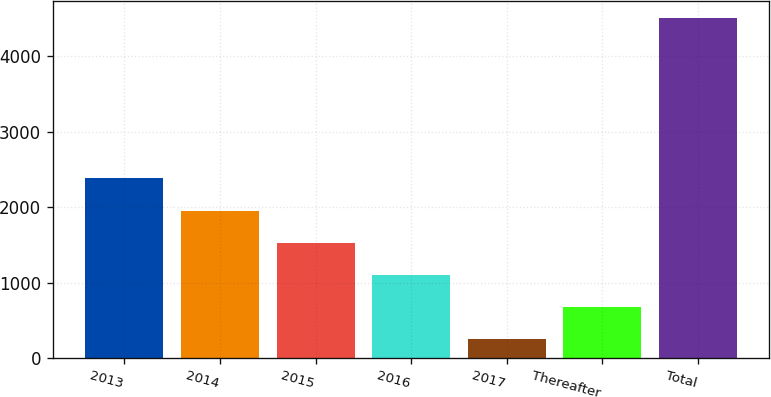Convert chart. <chart><loc_0><loc_0><loc_500><loc_500><bar_chart><fcel>2013<fcel>2014<fcel>2015<fcel>2016<fcel>2017<fcel>Thereafter<fcel>Total<nl><fcel>2381<fcel>1955.6<fcel>1530.2<fcel>1104.8<fcel>254<fcel>679.4<fcel>4508<nl></chart> 